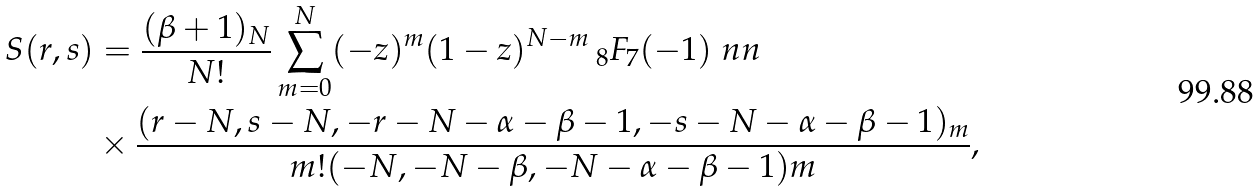<formula> <loc_0><loc_0><loc_500><loc_500>S ( r , s ) & = \frac { ( \beta + 1 ) _ { N } } { N ! } \sum _ { m = 0 } ^ { N } ( - z ) ^ { m } ( 1 - z ) ^ { N - m } { \, } _ { 8 } F _ { 7 } ( - 1 ) \ n n \\ & \times \frac { ( r - N , s - N , - r - N - \alpha - \beta - 1 , - s - N - \alpha - \beta - 1 ) _ { m } } { m ! ( - N , - N - \beta , - N - \alpha - \beta - 1 ) m } ,</formula> 